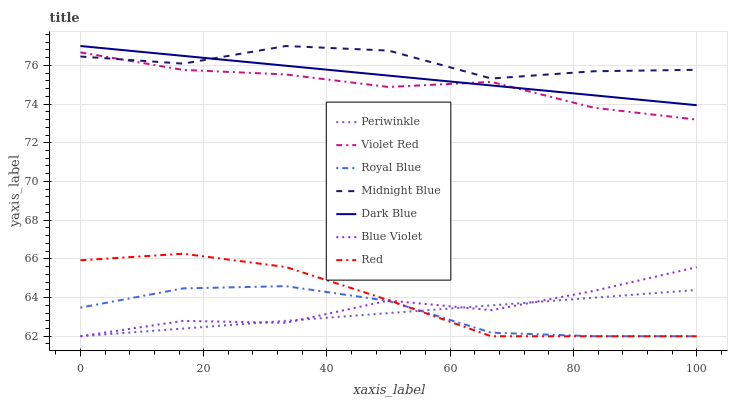Does Periwinkle have the minimum area under the curve?
Answer yes or no. Yes. Does Midnight Blue have the maximum area under the curve?
Answer yes or no. Yes. Does Dark Blue have the minimum area under the curve?
Answer yes or no. No. Does Dark Blue have the maximum area under the curve?
Answer yes or no. No. Is Periwinkle the smoothest?
Answer yes or no. Yes. Is Midnight Blue the roughest?
Answer yes or no. Yes. Is Dark Blue the smoothest?
Answer yes or no. No. Is Dark Blue the roughest?
Answer yes or no. No. Does Royal Blue have the lowest value?
Answer yes or no. Yes. Does Dark Blue have the lowest value?
Answer yes or no. No. Does Dark Blue have the highest value?
Answer yes or no. Yes. Does Royal Blue have the highest value?
Answer yes or no. No. Is Blue Violet less than Violet Red?
Answer yes or no. Yes. Is Midnight Blue greater than Red?
Answer yes or no. Yes. Does Violet Red intersect Dark Blue?
Answer yes or no. Yes. Is Violet Red less than Dark Blue?
Answer yes or no. No. Is Violet Red greater than Dark Blue?
Answer yes or no. No. Does Blue Violet intersect Violet Red?
Answer yes or no. No. 